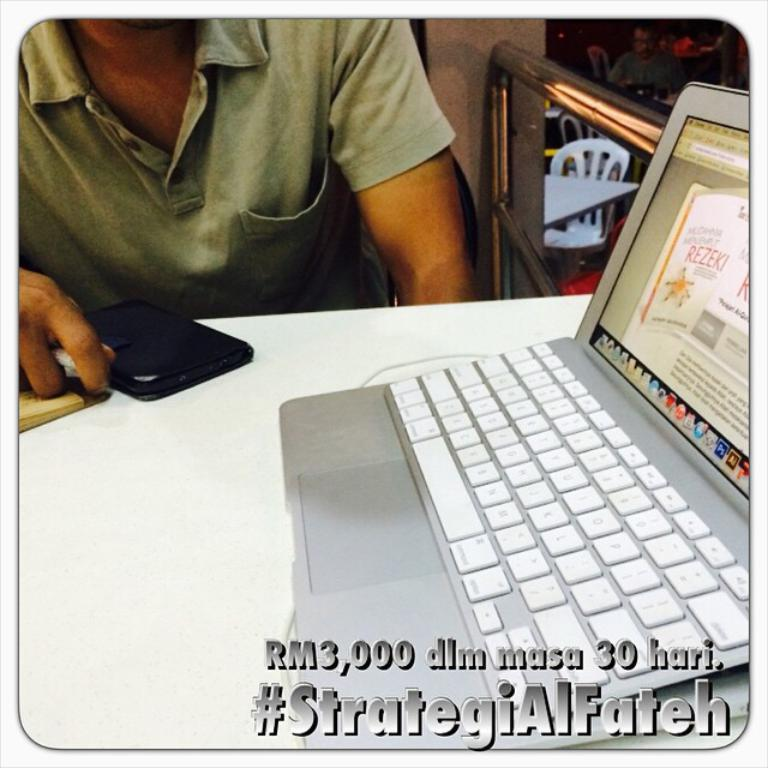Provide a one-sentence caption for the provided image. An open laptop on a table witha man sitting nearby captioned with the hashtag StrategiAlFateh. 